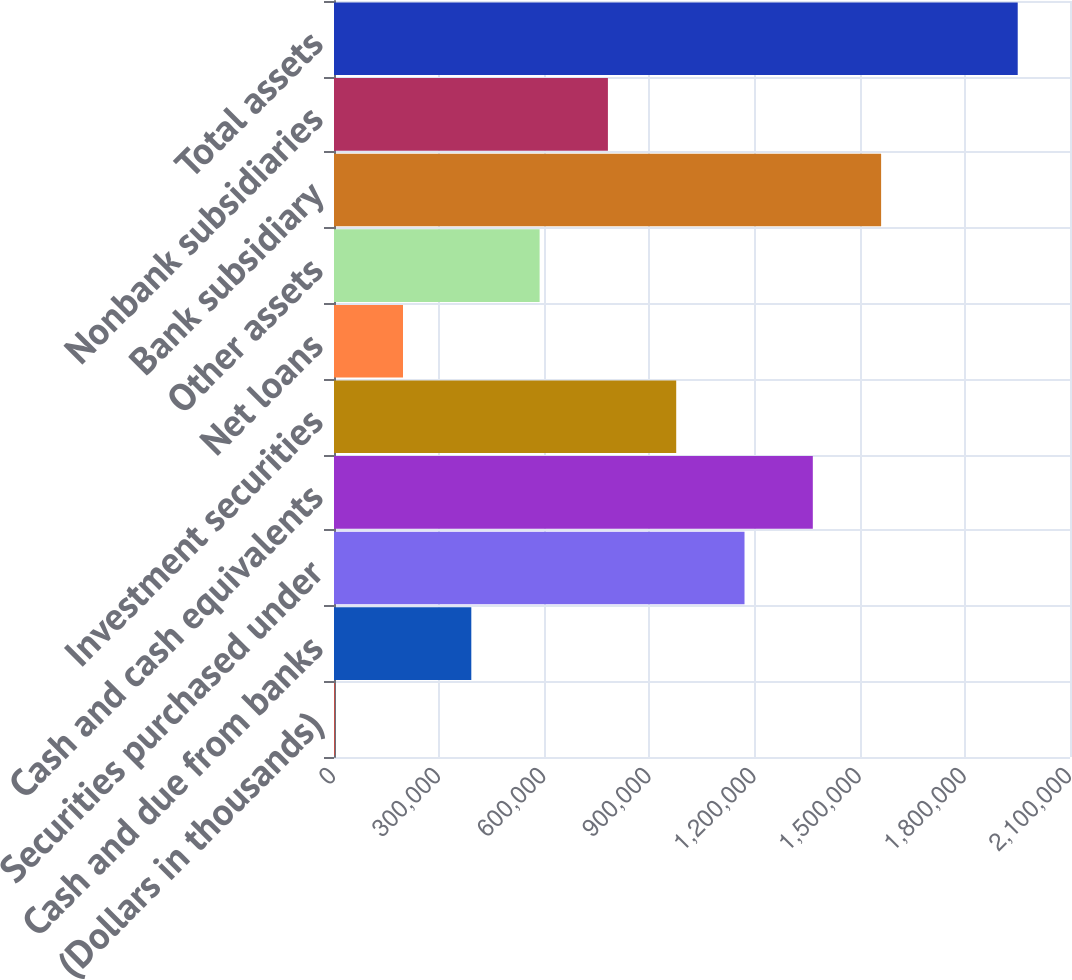Convert chart to OTSL. <chart><loc_0><loc_0><loc_500><loc_500><bar_chart><fcel>(Dollars in thousands)<fcel>Cash and due from banks<fcel>Securities purchased under<fcel>Cash and cash equivalents<fcel>Investment securities<fcel>Net loans<fcel>Other assets<fcel>Bank subsidiary<fcel>Nonbank subsidiaries<fcel>Total assets<nl><fcel>2010<fcel>391774<fcel>1.1713e+06<fcel>1.36618e+06<fcel>976420<fcel>196892<fcel>586656<fcel>1.56107e+06<fcel>781538<fcel>1.95083e+06<nl></chart> 